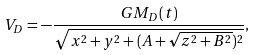<formula> <loc_0><loc_0><loc_500><loc_500>V _ { D } = - \frac { G M _ { D } ( t ) } { \sqrt { x ^ { 2 } + y ^ { 2 } + ( A + \sqrt { z ^ { 2 } + B ^ { 2 } } ) ^ { 2 } } } ,</formula> 